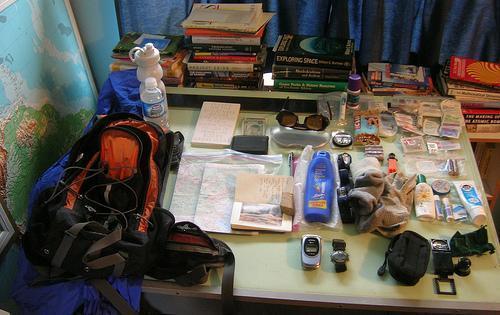How many water bottles are there?
Give a very brief answer. 2. 